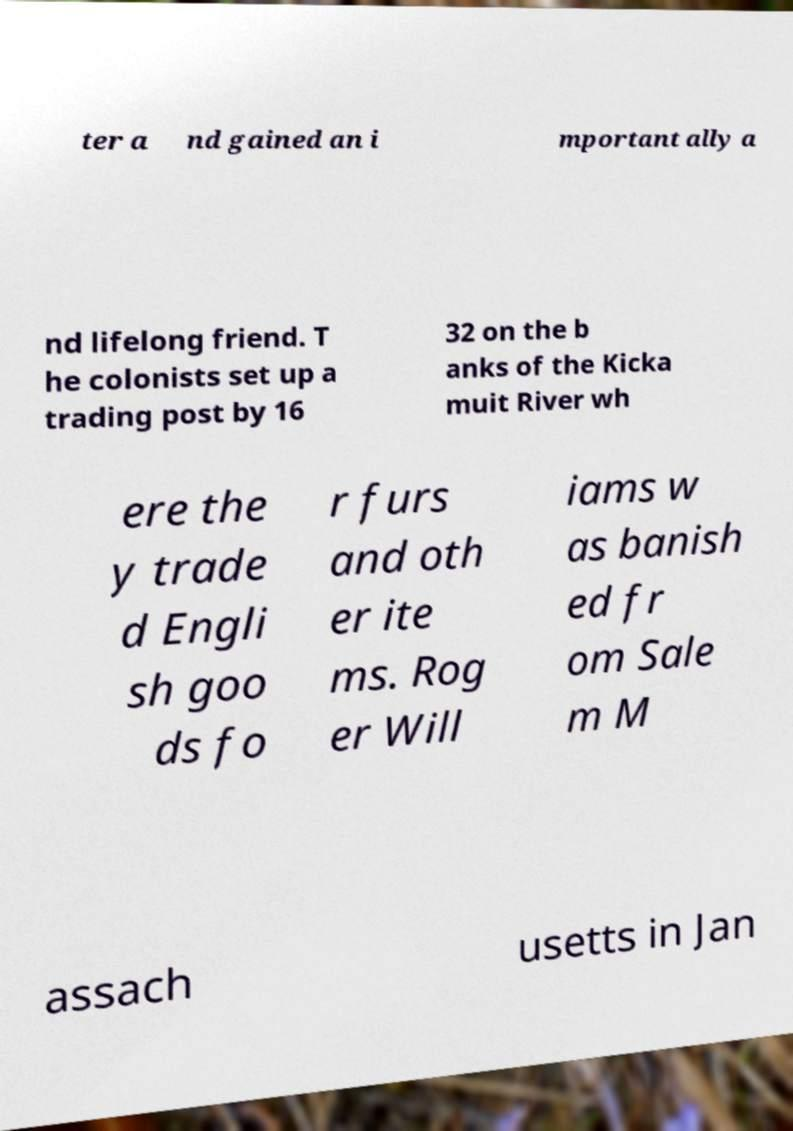Can you read and provide the text displayed in the image?This photo seems to have some interesting text. Can you extract and type it out for me? ter a nd gained an i mportant ally a nd lifelong friend. T he colonists set up a trading post by 16 32 on the b anks of the Kicka muit River wh ere the y trade d Engli sh goo ds fo r furs and oth er ite ms. Rog er Will iams w as banish ed fr om Sale m M assach usetts in Jan 